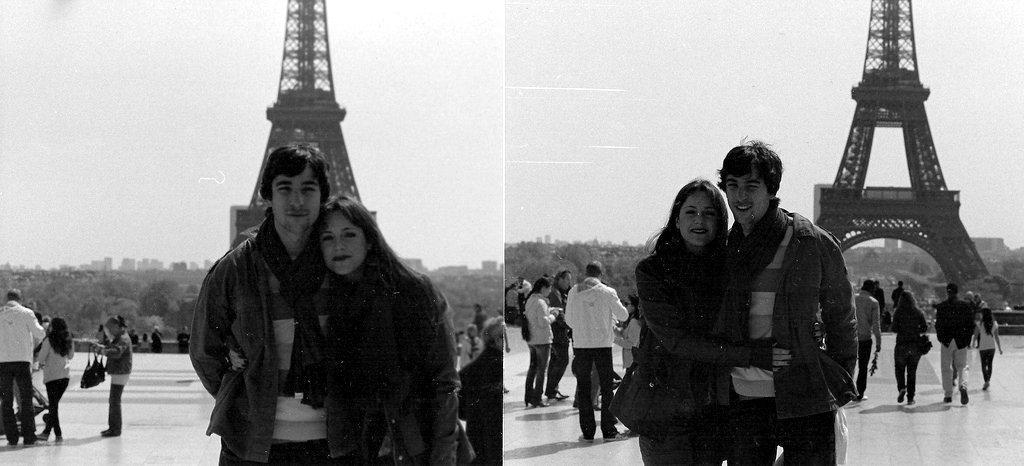How would you summarize this image in a sentence or two? This is a collage image. In this image I can see two pictures. In the two images, I can see a man and a woman are standing, smiling and giving pose for the picture. At the back of these people, I can see some other people. In the background there is a tower, trees and buildings. At the top of the image I can see the sky. These are black and white pictures. 